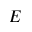Convert formula to latex. <formula><loc_0><loc_0><loc_500><loc_500>E</formula> 